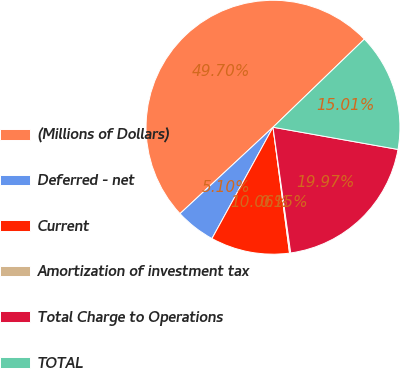Convert chart to OTSL. <chart><loc_0><loc_0><loc_500><loc_500><pie_chart><fcel>(Millions of Dollars)<fcel>Deferred - net<fcel>Current<fcel>Amortization of investment tax<fcel>Total Charge to Operations<fcel>TOTAL<nl><fcel>49.7%<fcel>5.1%<fcel>10.06%<fcel>0.15%<fcel>19.97%<fcel>15.01%<nl></chart> 